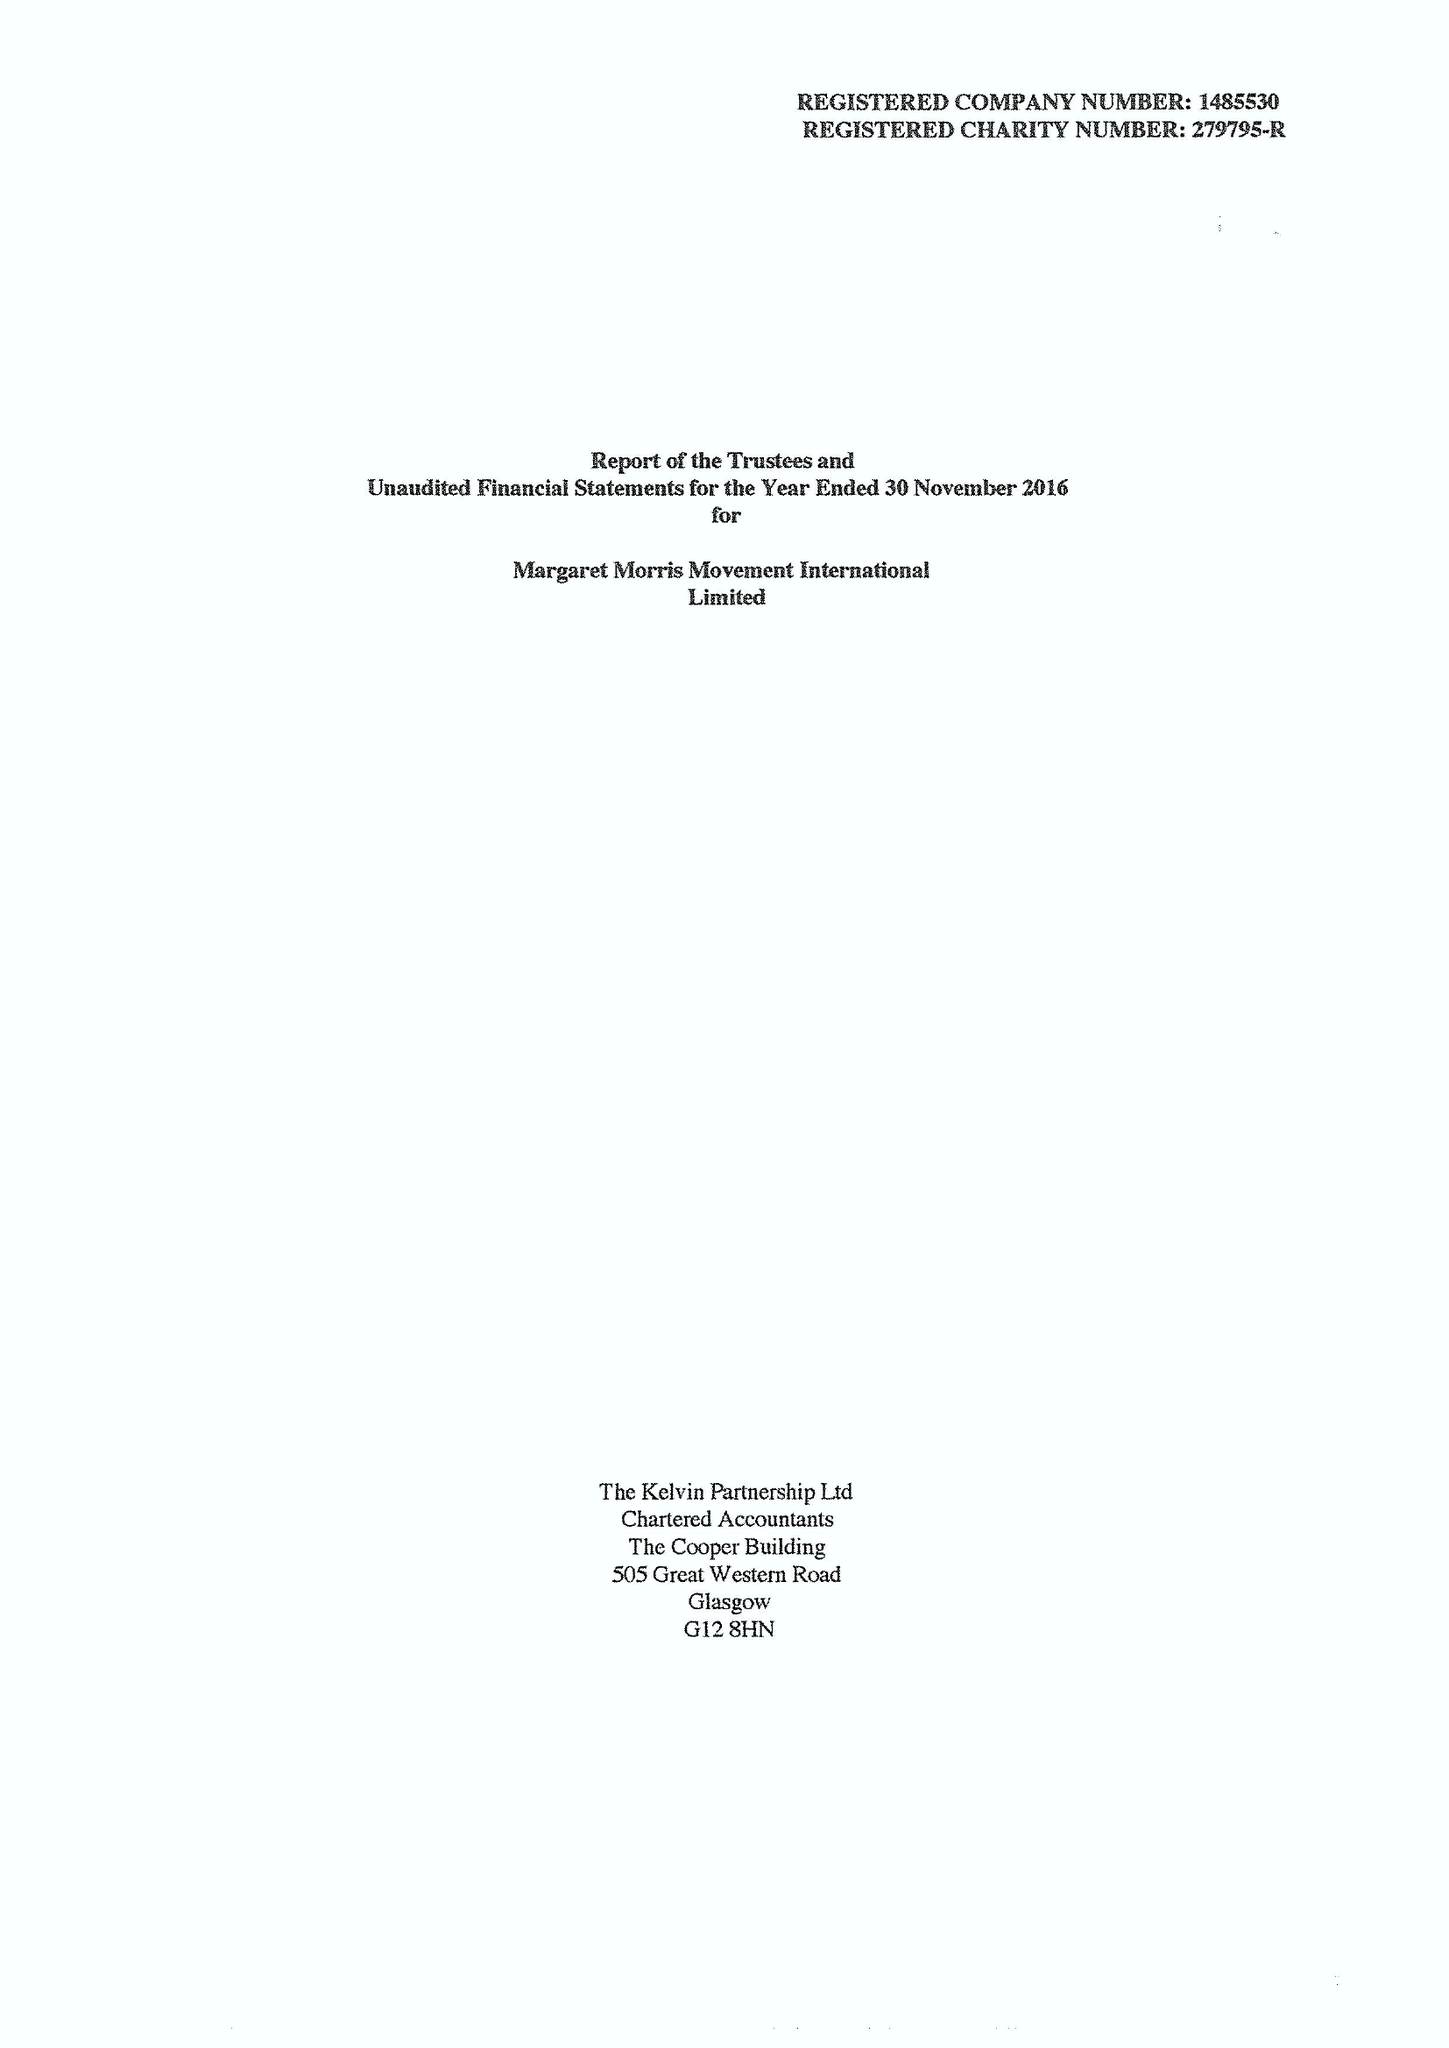What is the value for the spending_annually_in_british_pounds?
Answer the question using a single word or phrase. 99459.00 